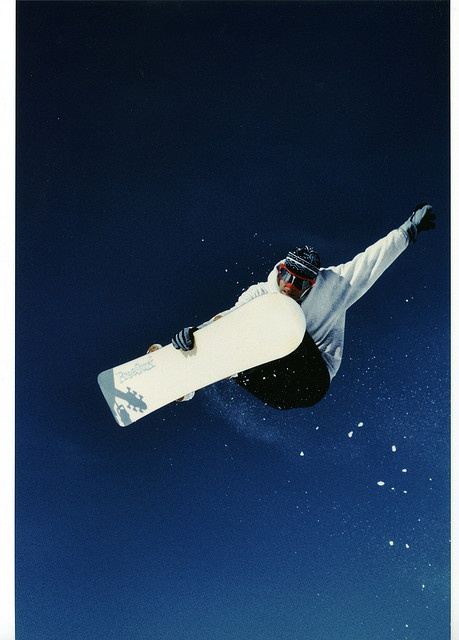Describe the objects in this image and their specific colors. I can see snowboard in white, beige, black, gray, and darkgray tones and people in white, black, darkgray, beige, and gray tones in this image. 